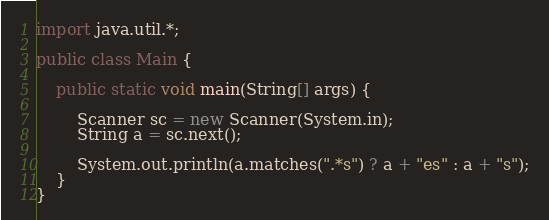Convert code to text. <code><loc_0><loc_0><loc_500><loc_500><_Java_>import java.util.*;

public class Main {

	public static void main(String[] args) {

		Scanner sc = new Scanner(System.in);
		String a = sc.next();

		System.out.println(a.matches(".*s") ? a + "es" : a + "s");
	}
}</code> 